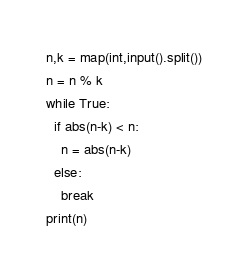Convert code to text. <code><loc_0><loc_0><loc_500><loc_500><_Python_>n,k = map(int,input().split())
n = n % k
while True:
  if abs(n-k) < n:
    n = abs(n-k)
  else:
    break
print(n)</code> 